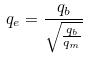<formula> <loc_0><loc_0><loc_500><loc_500>q _ { e } = \frac { q _ { b } } { \sqrt { \frac { q _ { b } } { q _ { m } } } }</formula> 